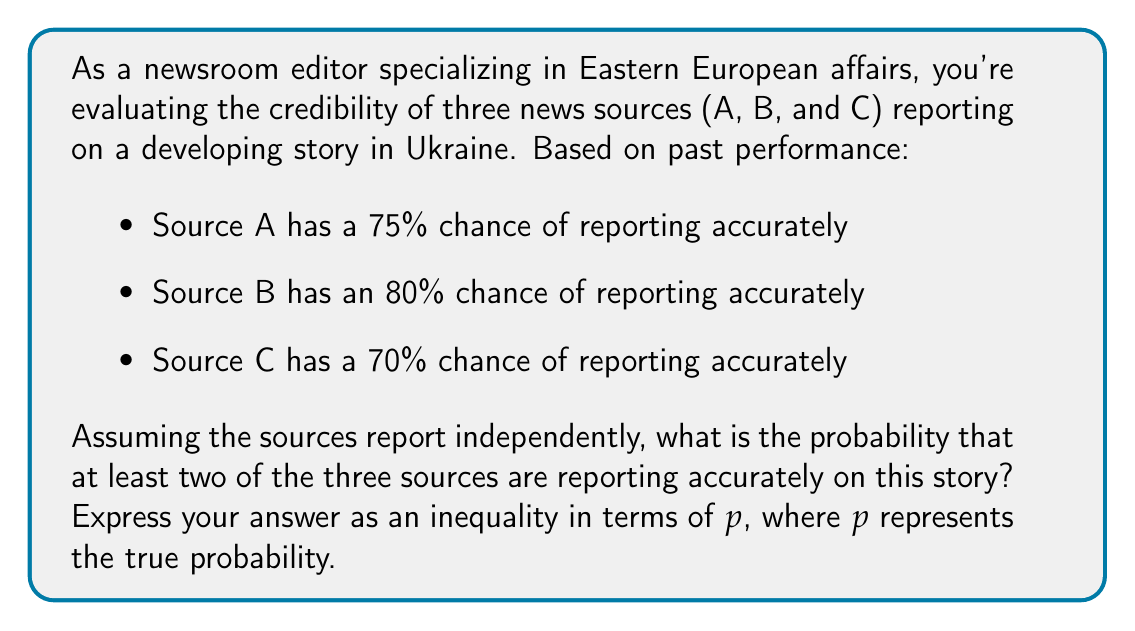Can you solve this math problem? To solve this problem, we'll use the concept of probability inequalities and the complement method.

1) First, let's calculate the probability of at least two sources reporting accurately:

   P(at least 2 accurate) = 1 - P(0 or 1 accurate)

2) Now, let's break down P(0 or 1 accurate):

   P(0 accurate) = 0.25 * 0.20 * 0.30 = 0.015
   
   P(1 accurate) = (0.75 * 0.20 * 0.30) + (0.25 * 0.80 * 0.30) + (0.25 * 0.20 * 0.70)
                 = 0.045 + 0.060 + 0.035 = 0.140

3) Therefore:

   P(at least 2 accurate) = 1 - (0.015 + 0.140) = 0.845

4) Now, to express this as an inequality in terms of $p$, we can say that the true probability $p$ is likely to be close to our calculated value, but may not be exact due to potential biases or errors in our past performance data.

5) A common approach is to use the Chebyshev inequality to create a confidence interval. However, for simplicity, we'll use a more straightforward inequality:

   $0.825 \leq p \leq 0.865$

This inequality suggests that we're reasonably confident that the true probability lies within 0.02 of our calculated value.
Answer: $0.825 \leq p \leq 0.865$, where $p$ is the true probability that at least two of the three sources are reporting accurately. 